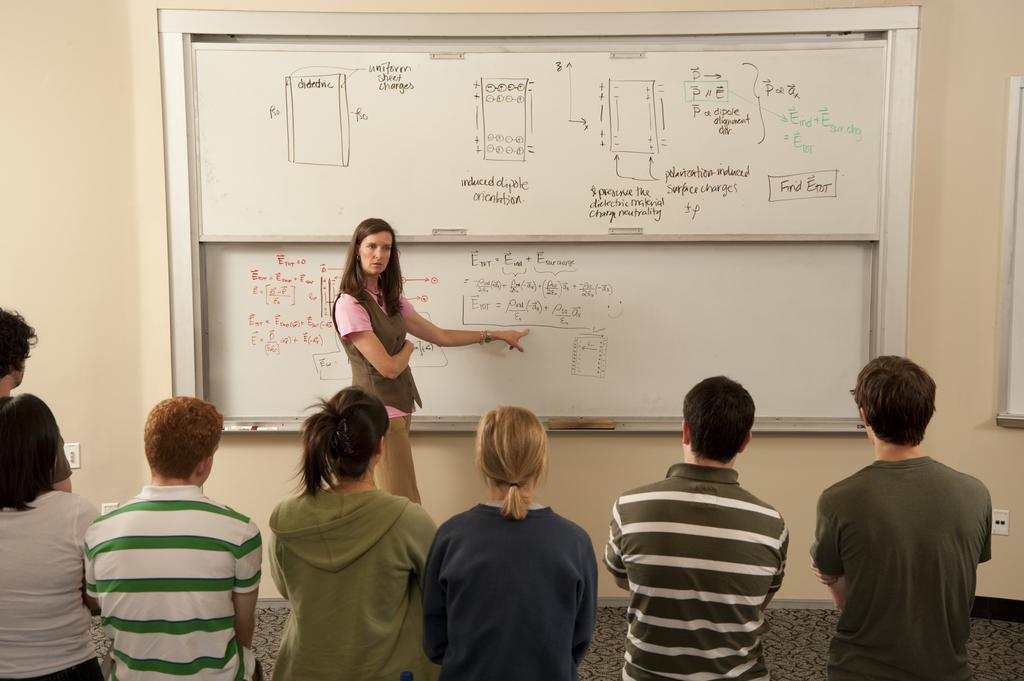How many people are in the image? There is a group of people in the foreground of the image. What is the position of the people in relation to the floor? The people are standing on the floor. What object can be seen in the image that is typically used for writing or displaying information? There is a whiteboard in the image. What type of structure is visible in the image? There is a wall visible in the image. Based on the presence of a group of people and a whiteboard, where might this image have been taken? The image might have been taken in a hall. What type of bulb is hanging from the ceiling in the image? There is no bulb visible in the image. How do the people in the image react to the sudden appearance of an island? There is no island present in the image, and therefore no reaction to it can be observed. 